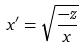Convert formula to latex. <formula><loc_0><loc_0><loc_500><loc_500>x ^ { \prime } = \sqrt { \frac { - z } { x } }</formula> 